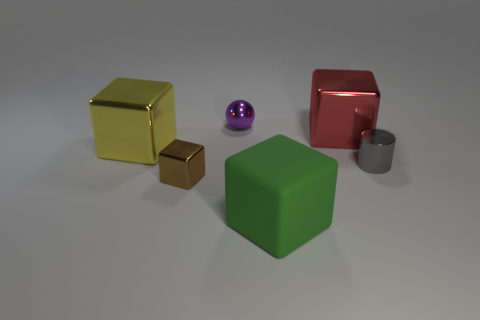Do the tiny thing that is right of the red cube and the tiny purple ball have the same material? yes 